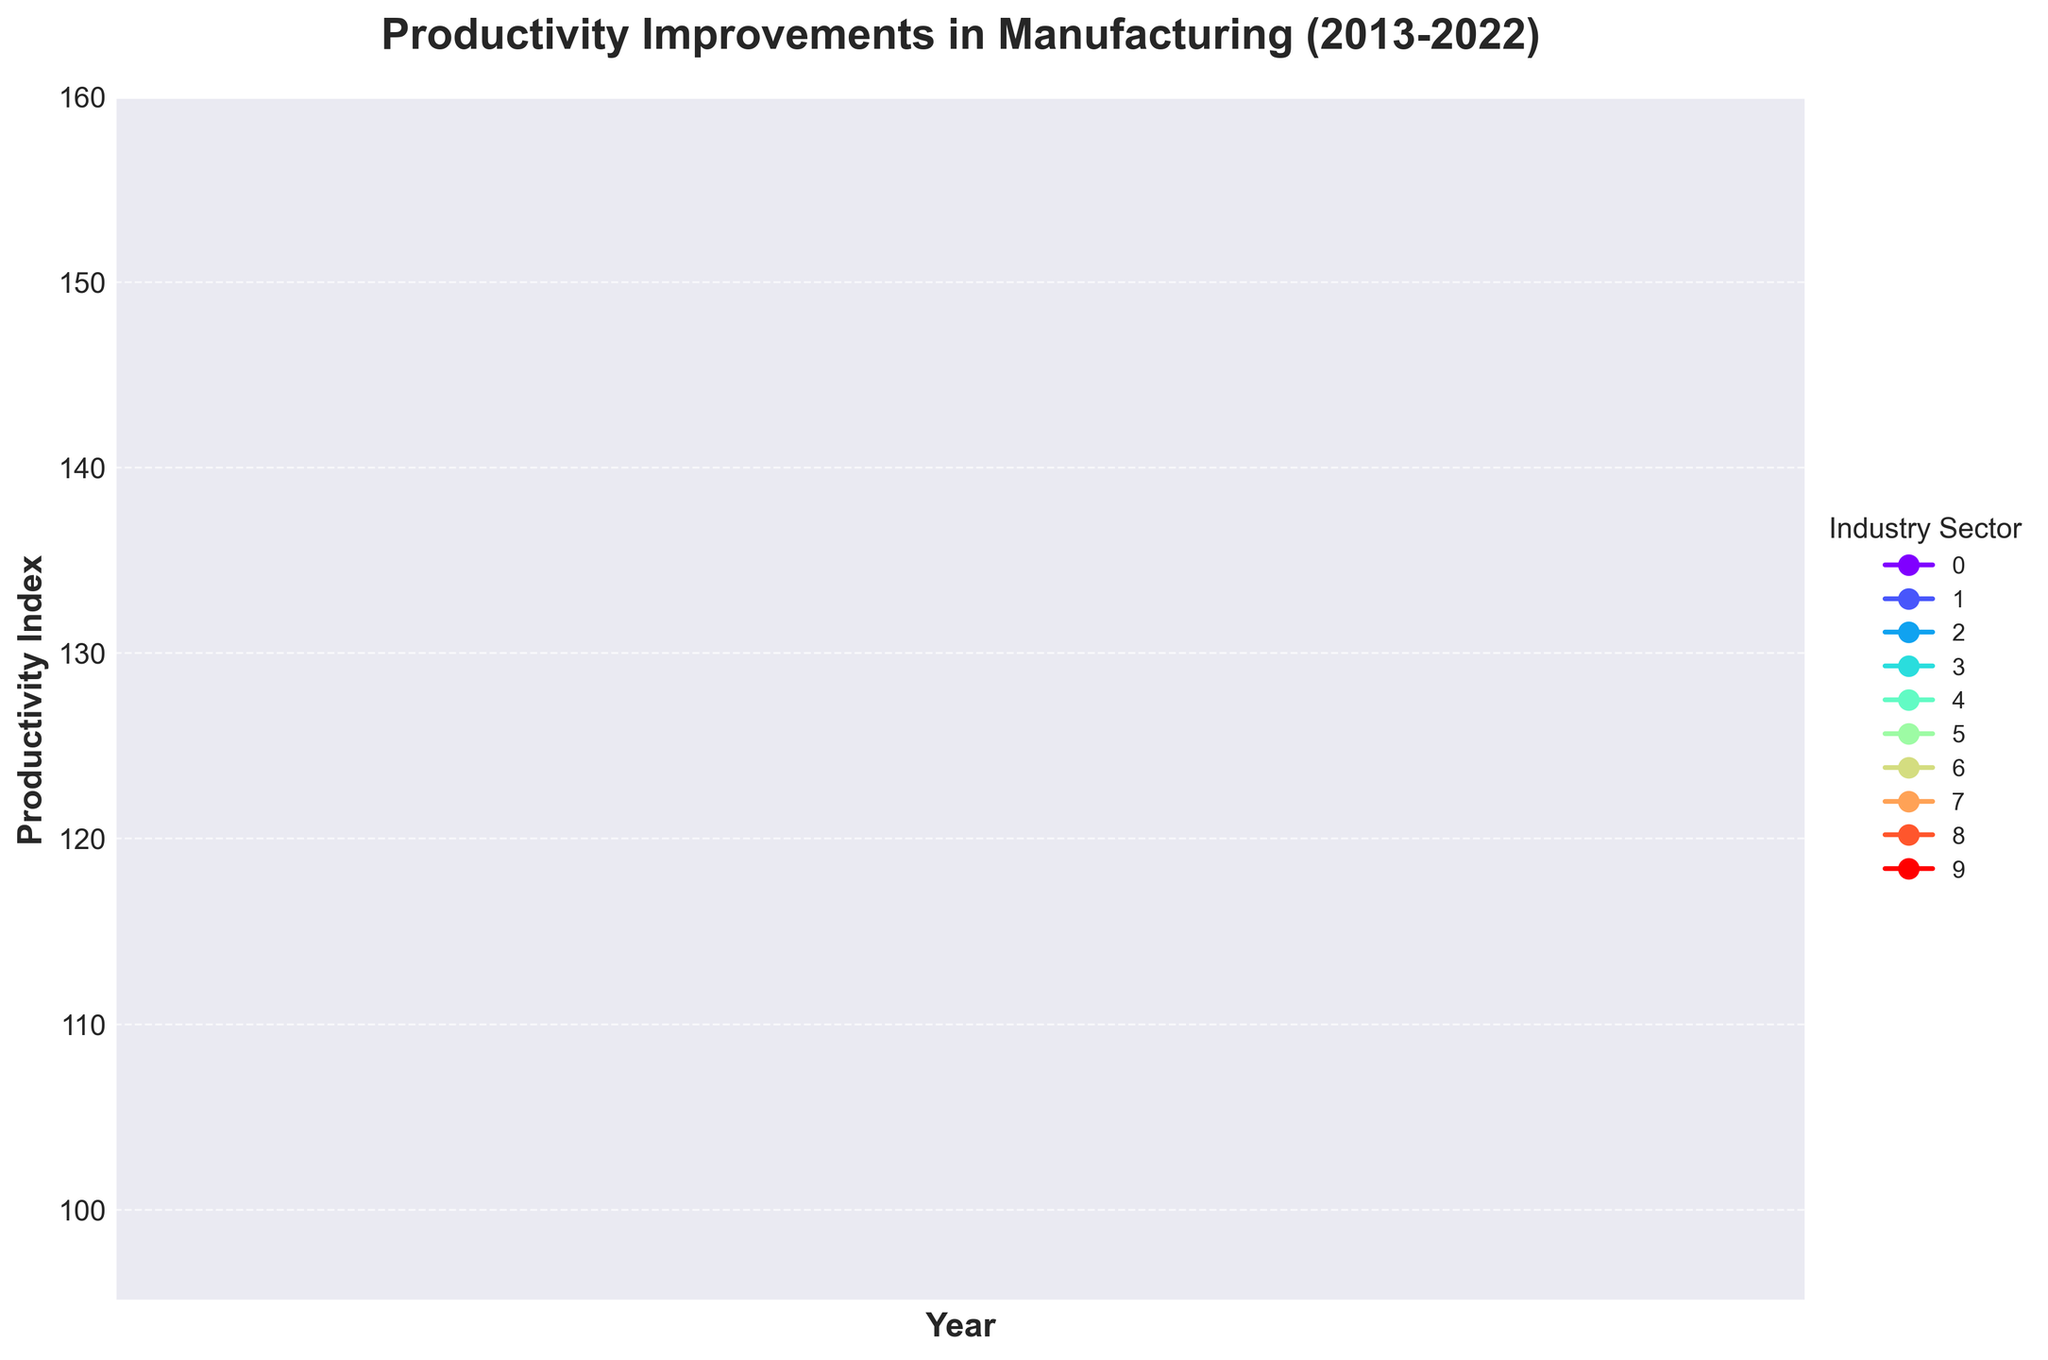What was the productivity index for the Electronics sector in 2020? Refer to the line that represents the Electronics sector and locate its value on the y-axis at the year 2020.
Answer: 138 Which industry sector had the highest productivity index in 2022? Identify the line that reaches the highest point on the y-axis in the year 2022.
Answer: Pharmaceutical Between 2013 and 2022, which industry sector showed the least overall improvement in productivity? Calculate the difference in productivity values from 2013 to 2022 for each sector. The sector with the smallest difference had the least improvement.
Answer: Food and Beverage How does the productivity index of the Automotive sector in 2020 compare to that in 2015? Locate the Automotive sector line and compare its 2015 value on the y-axis to its 2020 value.
Answer: It decreased What is the average productivity index for the Aerospace sector from 2019 to 2022? Find the values for Aerospace in the years 2019, 2020, 2021, and 2022. Sum these values and then divide by the number of years (4).
Answer: (118 + 116 + 120 + 124) / 4 = 119.5 Which two industry sectors had identical productivity indices in any year? Scan the chart to find where any two lines intersect or overlap at specific years.
Answer: Automotive and Metal Fabrication in 2013 By how much did the productivity index in the Textile sector change between 2018 and 2020? Subtract the Textile sector's productivity index in 2018 from its index in 2020.
Answer: 109 - 108 = 1 In which year did the Chemical sector first surpass a productivity index of 130? Locate the Chemical sector line and note the first year it goes above a y-axis value of 130.
Answer: 2021 What is the difference in the productivity index between the Electronics and Automotive sectors in 2022? Find the productivity indices for both sectors in 2022 and subtract the Automotive sector’s index from the Electronics sector’s index.
Answer: 153 - 129 = 24 Which sector exhibited the second-largest improvement in productivity from 2013 to 2022? Calculate the change in productivity index for each sector from 2013 to 2022. Rank the changes to identify the second largest.
Answer: Pharmaceutical (57) and Electronics (53), so Electronics is the second-largest improvement 